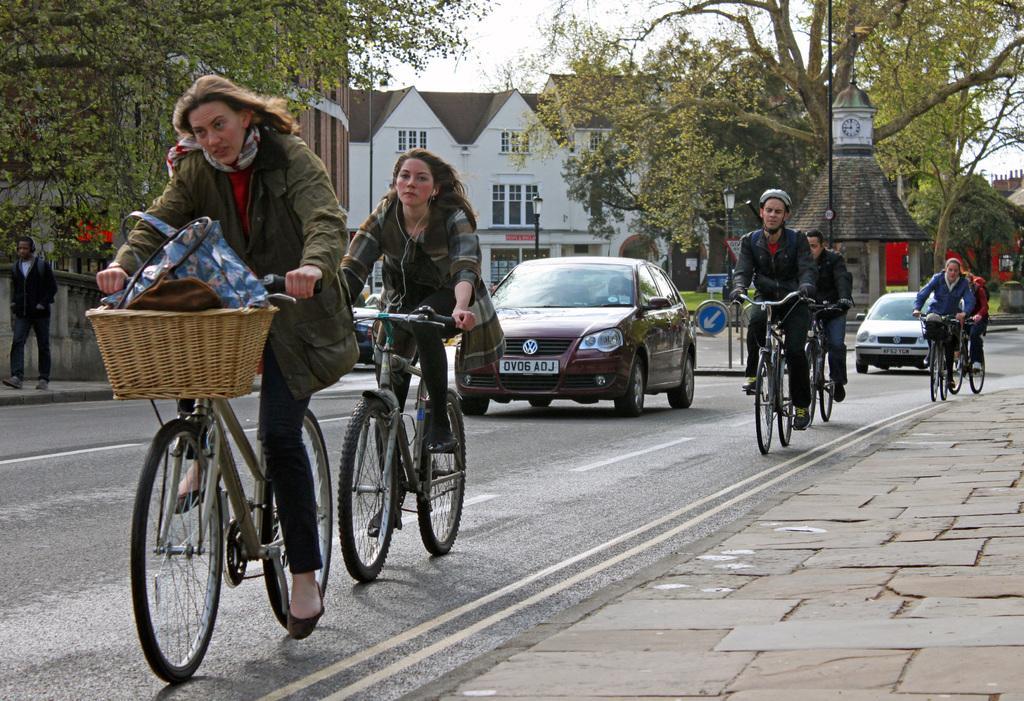Describe this image in one or two sentences. In this image i can see few persons riding bicycle on a road i can also see a car on the road, at the back ground i can see a man walking on the foot path,a tree ,a house and a sky. 